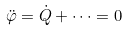<formula> <loc_0><loc_0><loc_500><loc_500>{ \ddot { \varphi } } = { \dot { Q } } + \dots = 0</formula> 